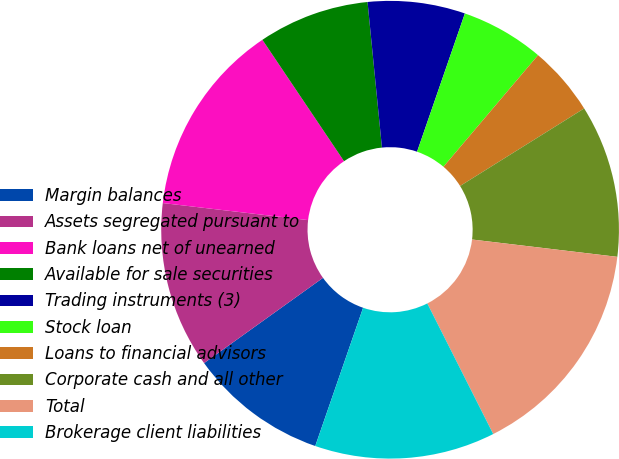<chart> <loc_0><loc_0><loc_500><loc_500><pie_chart><fcel>Margin balances<fcel>Assets segregated pursuant to<fcel>Bank loans net of unearned<fcel>Available for sale securities<fcel>Trading instruments (3)<fcel>Stock loan<fcel>Loans to financial advisors<fcel>Corporate cash and all other<fcel>Total<fcel>Brokerage client liabilities<nl><fcel>9.8%<fcel>11.76%<fcel>13.72%<fcel>7.85%<fcel>6.87%<fcel>5.89%<fcel>4.92%<fcel>10.78%<fcel>15.67%<fcel>12.74%<nl></chart> 